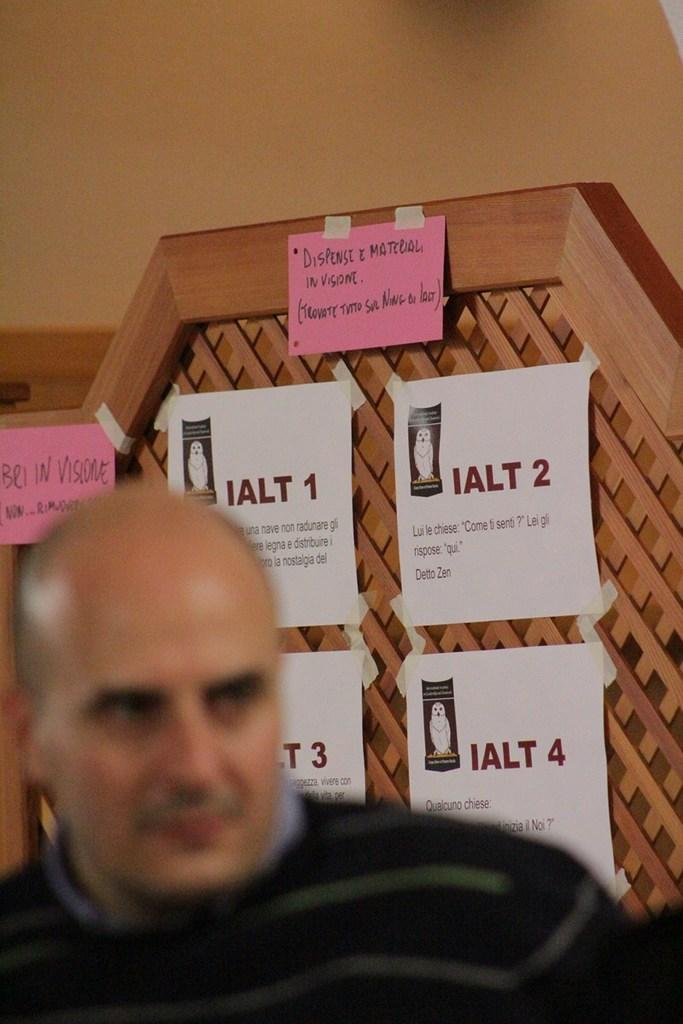Who is present in the image? There is a man in the image. What is the man wearing? The man is wearing a black shirt. What can be seen in the background of the image? There is a wood wall in the background of the image. What is attached to the wood wall in the background? Papers are attached to the wood wall in the background. What type of knee injury does the man appear to have in the image? There is no indication of a knee injury in the image; the man's legs are not visible. --- Facts: 1. There is a cat in the image. 2. The cat is sitting on a chair. 3. The chair has a patterned fabric. 4. There is a window in the background of the image. 5. The window has curtains. Absurd Topics: bicycle, ocean, guitar Conversation: What animal is present in the image? There is a cat in the image. What is the cat doing in the image? The cat is sitting on a chair. Can you describe the chair the cat is sitting on? The chair has a patterned fabric. What can be seen in the background of the image? There is a window in the background of the image. What type of window treatment is present in the image? The window has curtains. Reasoning: Let's think step by step in order to produce the conversation. We start by identifying the main subject in the image, which is the cat. Then, we describe what the cat is doing, which is sitting on a chair. Next, we focus on the chair, mentioning its patterned fabric. We then shift our attention to the background of the image, mentioning the window. Finally, we describe the window treatment, which are curtains. Each question is designed to elicit a specific detail about the image that is known from the provided facts. Absurd Question/Answer: What type of bicycle is the cat riding in the image? There is no 